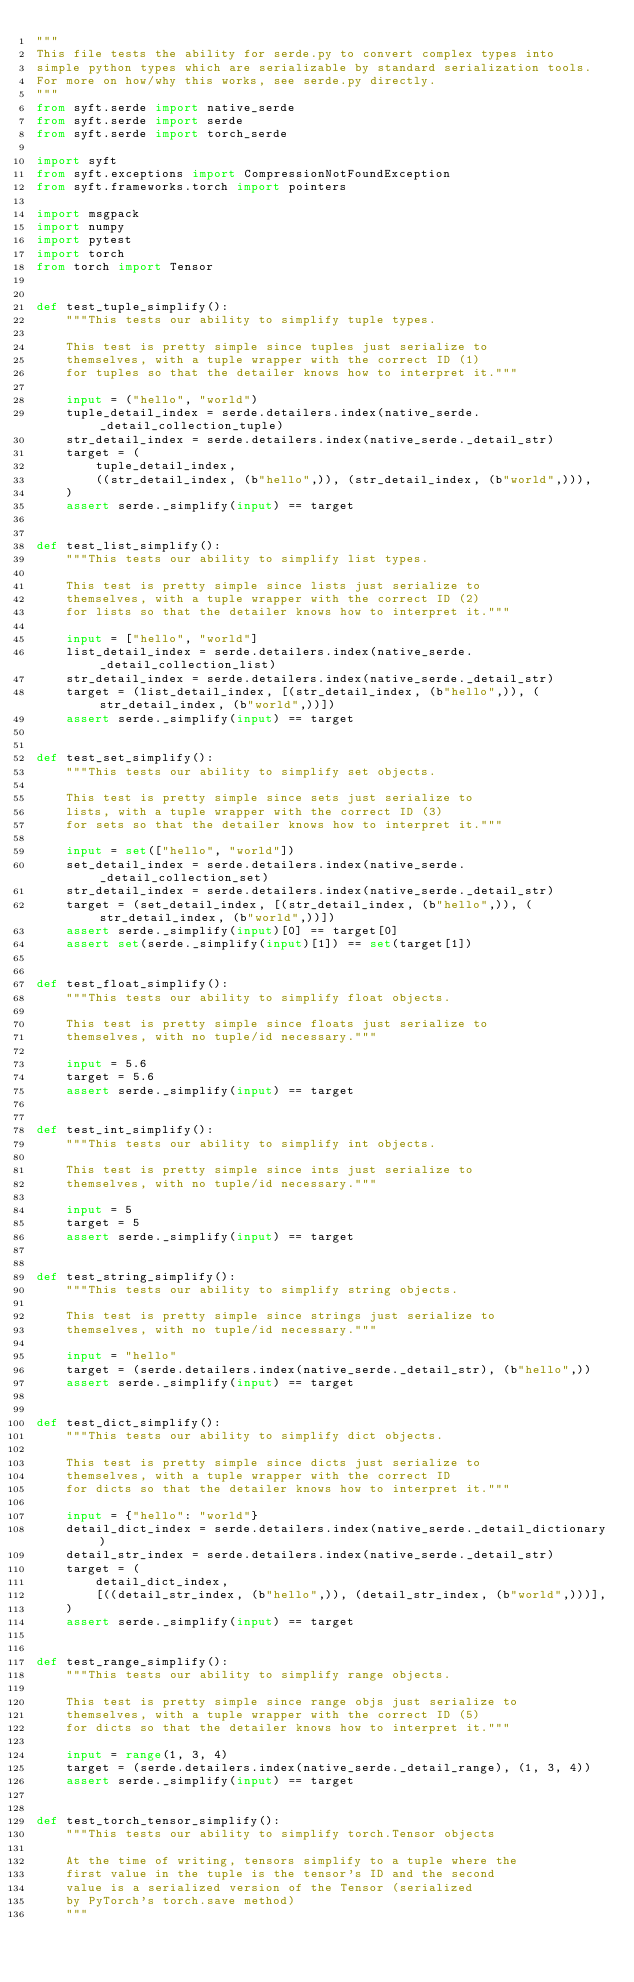Convert code to text. <code><loc_0><loc_0><loc_500><loc_500><_Python_>"""
This file tests the ability for serde.py to convert complex types into
simple python types which are serializable by standard serialization tools.
For more on how/why this works, see serde.py directly.
"""
from syft.serde import native_serde
from syft.serde import serde
from syft.serde import torch_serde

import syft
from syft.exceptions import CompressionNotFoundException
from syft.frameworks.torch import pointers

import msgpack
import numpy
import pytest
import torch
from torch import Tensor


def test_tuple_simplify():
    """This tests our ability to simplify tuple types.

    This test is pretty simple since tuples just serialize to
    themselves, with a tuple wrapper with the correct ID (1)
    for tuples so that the detailer knows how to interpret it."""

    input = ("hello", "world")
    tuple_detail_index = serde.detailers.index(native_serde._detail_collection_tuple)
    str_detail_index = serde.detailers.index(native_serde._detail_str)
    target = (
        tuple_detail_index,
        ((str_detail_index, (b"hello",)), (str_detail_index, (b"world",))),
    )
    assert serde._simplify(input) == target


def test_list_simplify():
    """This tests our ability to simplify list types.

    This test is pretty simple since lists just serialize to
    themselves, with a tuple wrapper with the correct ID (2)
    for lists so that the detailer knows how to interpret it."""

    input = ["hello", "world"]
    list_detail_index = serde.detailers.index(native_serde._detail_collection_list)
    str_detail_index = serde.detailers.index(native_serde._detail_str)
    target = (list_detail_index, [(str_detail_index, (b"hello",)), (str_detail_index, (b"world",))])
    assert serde._simplify(input) == target


def test_set_simplify():
    """This tests our ability to simplify set objects.

    This test is pretty simple since sets just serialize to
    lists, with a tuple wrapper with the correct ID (3)
    for sets so that the detailer knows how to interpret it."""

    input = set(["hello", "world"])
    set_detail_index = serde.detailers.index(native_serde._detail_collection_set)
    str_detail_index = serde.detailers.index(native_serde._detail_str)
    target = (set_detail_index, [(str_detail_index, (b"hello",)), (str_detail_index, (b"world",))])
    assert serde._simplify(input)[0] == target[0]
    assert set(serde._simplify(input)[1]) == set(target[1])


def test_float_simplify():
    """This tests our ability to simplify float objects.

    This test is pretty simple since floats just serialize to
    themselves, with no tuple/id necessary."""

    input = 5.6
    target = 5.6
    assert serde._simplify(input) == target


def test_int_simplify():
    """This tests our ability to simplify int objects.

    This test is pretty simple since ints just serialize to
    themselves, with no tuple/id necessary."""

    input = 5
    target = 5
    assert serde._simplify(input) == target


def test_string_simplify():
    """This tests our ability to simplify string objects.

    This test is pretty simple since strings just serialize to
    themselves, with no tuple/id necessary."""

    input = "hello"
    target = (serde.detailers.index(native_serde._detail_str), (b"hello",))
    assert serde._simplify(input) == target


def test_dict_simplify():
    """This tests our ability to simplify dict objects.

    This test is pretty simple since dicts just serialize to
    themselves, with a tuple wrapper with the correct ID
    for dicts so that the detailer knows how to interpret it."""

    input = {"hello": "world"}
    detail_dict_index = serde.detailers.index(native_serde._detail_dictionary)
    detail_str_index = serde.detailers.index(native_serde._detail_str)
    target = (
        detail_dict_index,
        [((detail_str_index, (b"hello",)), (detail_str_index, (b"world",)))],
    )
    assert serde._simplify(input) == target


def test_range_simplify():
    """This tests our ability to simplify range objects.

    This test is pretty simple since range objs just serialize to
    themselves, with a tuple wrapper with the correct ID (5)
    for dicts so that the detailer knows how to interpret it."""

    input = range(1, 3, 4)
    target = (serde.detailers.index(native_serde._detail_range), (1, 3, 4))
    assert serde._simplify(input) == target


def test_torch_tensor_simplify():
    """This tests our ability to simplify torch.Tensor objects

    At the time of writing, tensors simplify to a tuple where the
    first value in the tuple is the tensor's ID and the second
    value is a serialized version of the Tensor (serialized
    by PyTorch's torch.save method)
    """
</code> 